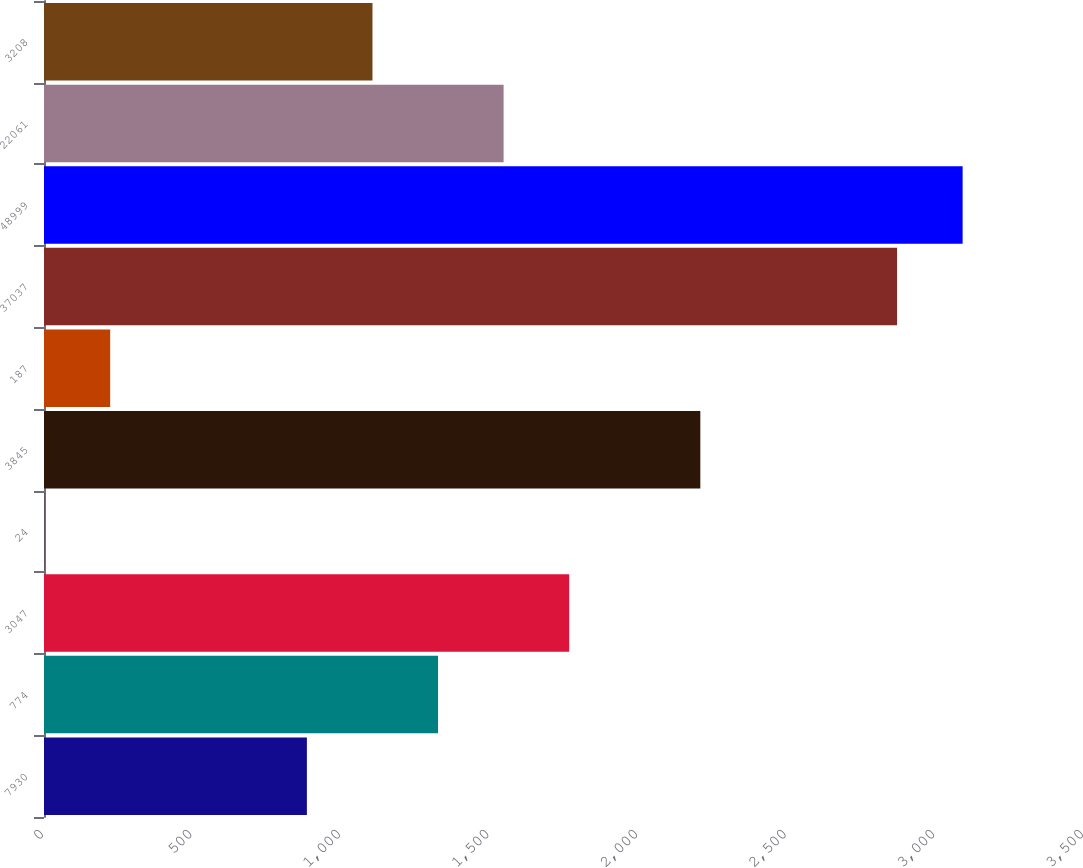Convert chart to OTSL. <chart><loc_0><loc_0><loc_500><loc_500><bar_chart><fcel>7930<fcel>774<fcel>3047<fcel>24<fcel>3845<fcel>187<fcel>37037<fcel>48999<fcel>22061<fcel>3208<nl><fcel>884.72<fcel>1326.08<fcel>1767.44<fcel>2<fcel>2208.8<fcel>222.68<fcel>2870.84<fcel>3091.52<fcel>1546.76<fcel>1105.4<nl></chart> 